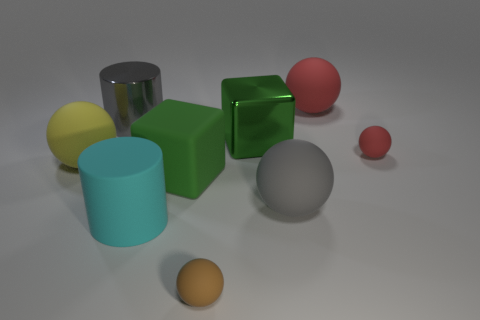Subtract all gray rubber spheres. How many spheres are left? 4 Add 1 large gray shiny cylinders. How many objects exist? 10 Subtract all cyan cylinders. How many cylinders are left? 1 Add 5 gray metal cylinders. How many gray metal cylinders are left? 6 Add 3 big gray spheres. How many big gray spheres exist? 4 Subtract 0 red cubes. How many objects are left? 9 Subtract all blocks. How many objects are left? 7 Subtract 1 balls. How many balls are left? 4 Subtract all blue cylinders. Subtract all blue blocks. How many cylinders are left? 2 Subtract all red spheres. How many cyan cylinders are left? 1 